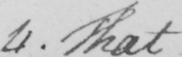What does this handwritten line say? 4 . That  _ 